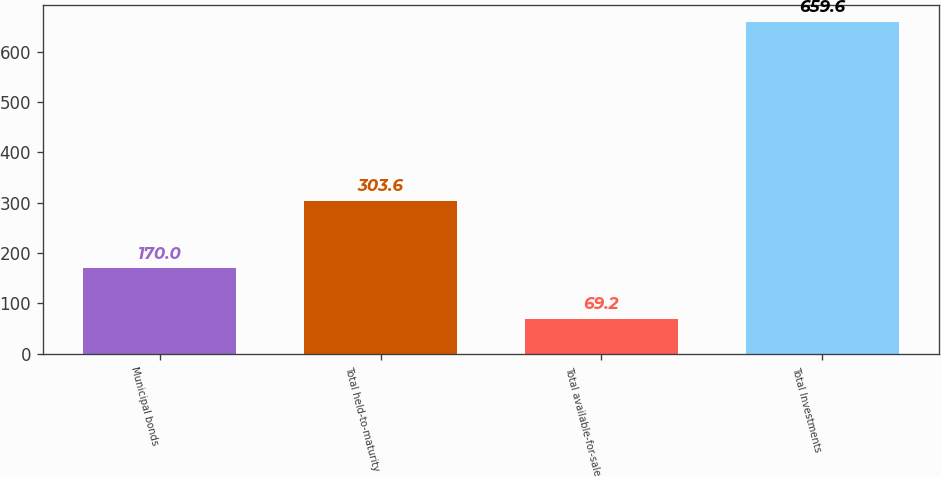<chart> <loc_0><loc_0><loc_500><loc_500><bar_chart><fcel>Municipal bonds<fcel>Total held-to-maturity<fcel>Total available-for-sale<fcel>Total Investments<nl><fcel>170<fcel>303.6<fcel>69.2<fcel>659.6<nl></chart> 